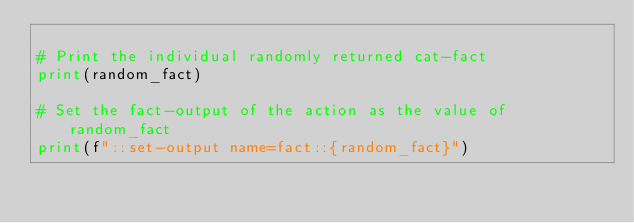Convert code to text. <code><loc_0><loc_0><loc_500><loc_500><_Python_>
# Print the individual randomly returned cat-fact
print(random_fact)

# Set the fact-output of the action as the value of random_fact
print(f"::set-output name=fact::{random_fact}")
</code> 